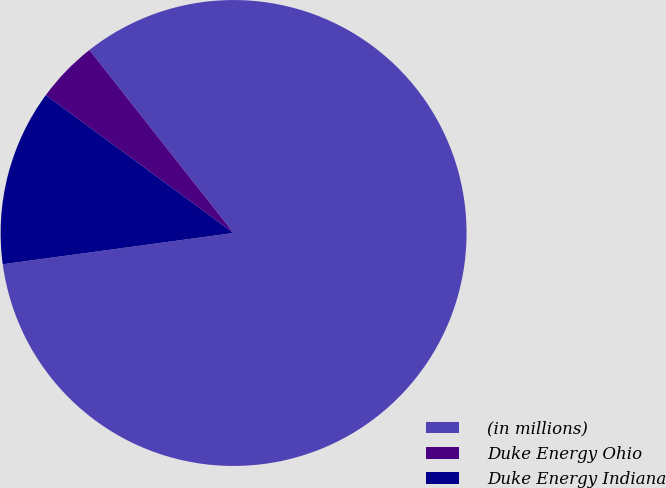Convert chart to OTSL. <chart><loc_0><loc_0><loc_500><loc_500><pie_chart><fcel>(in millions)<fcel>Duke Energy Ohio<fcel>Duke Energy Indiana<nl><fcel>83.47%<fcel>4.3%<fcel>12.22%<nl></chart> 